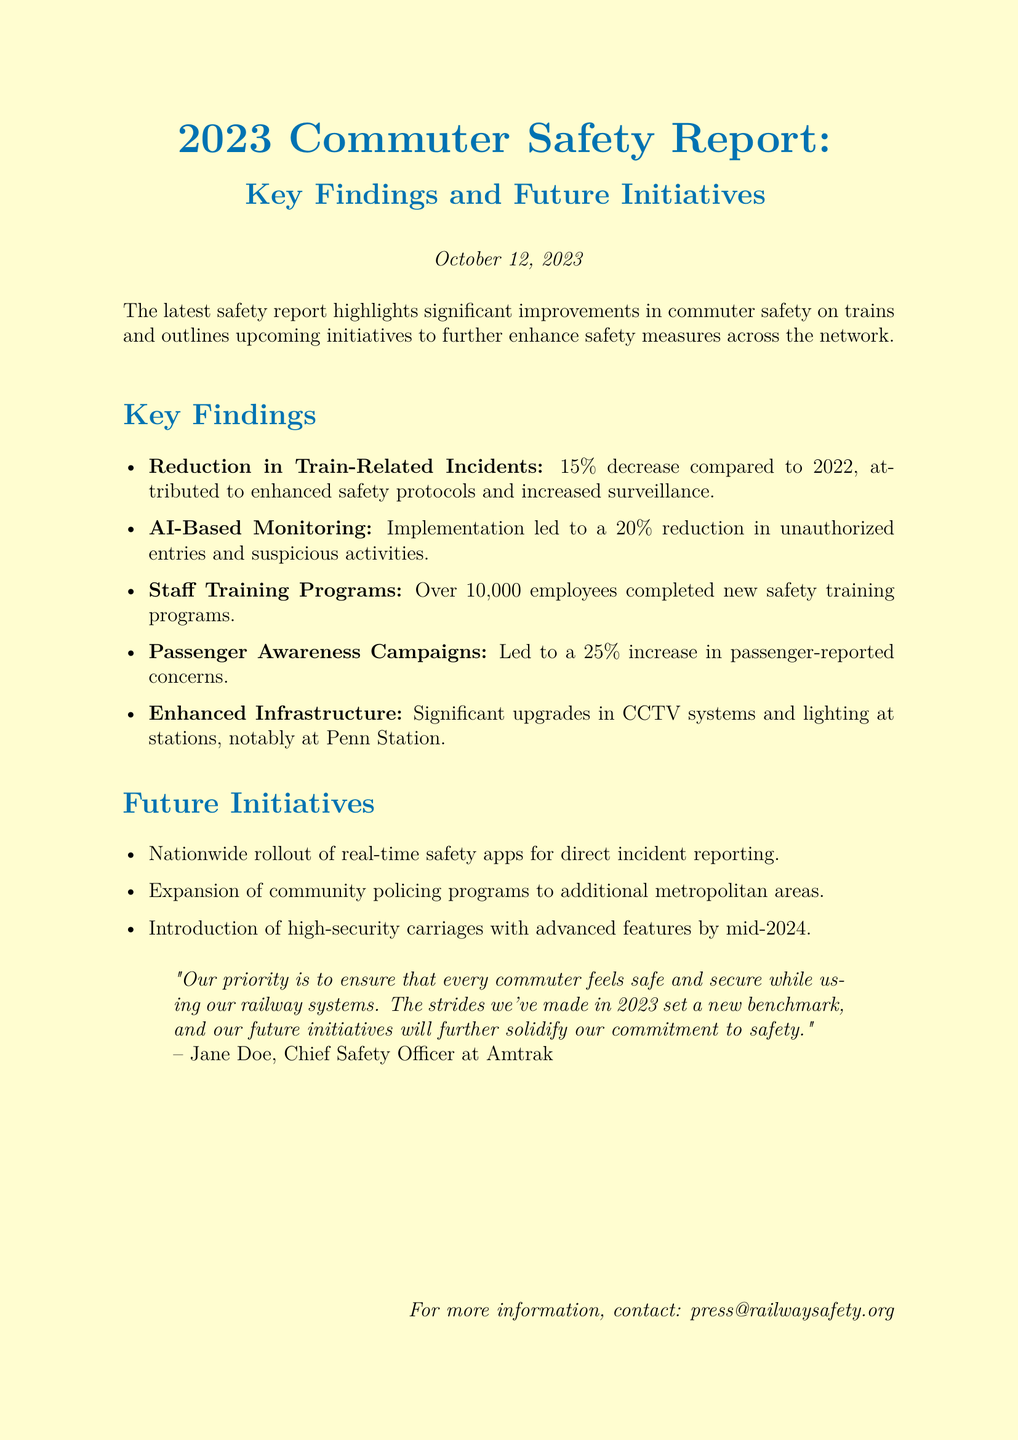What is the percentage decrease in train-related incidents compared to 2022? The document states that there was a 15% decrease in train-related incidents attributed to enhanced safety protocols.
Answer: 15% How many employees completed the new safety training programs? The report mentions that over 10,000 employees have completed the new safety training programs.
Answer: Over 10,000 What is the anticipated completion date for the introduction of high-security carriages? The document specifies that the high-security carriages with advanced features will be introduced by mid-2024.
Answer: Mid-2024 What was the increase in passenger-reported concerns due to the awareness campaigns? The report indicates that there was a 25% increase in passenger-reported concerns as a result of the awareness campaigns.
Answer: 25% Who is the Chief Safety Officer at Amtrak? The document quotes Jane Doe as the Chief Safety Officer at Amtrak.
Answer: Jane Doe What new technology contributed to the reduction in unauthorized entries? The implementation of AI-based monitoring contributed to a 20% reduction in unauthorized entries and suspicious activities.
Answer: AI-Based Monitoring What future initiative involves real-time safety apps? The document outlines a nationwide rollout of real-time safety apps for direct incident reporting as a future initiative.
Answer: Real-time safety apps What kind of upgrades were made to the infrastructure at stations? The report mentions significant upgrades in CCTV systems and lighting at stations.
Answer: CCTV systems and lighting What is the main priority of the railway safety initiatives? The document states that the main priority is to ensure that every commuter feels safe and secure.
Answer: Safety and security 